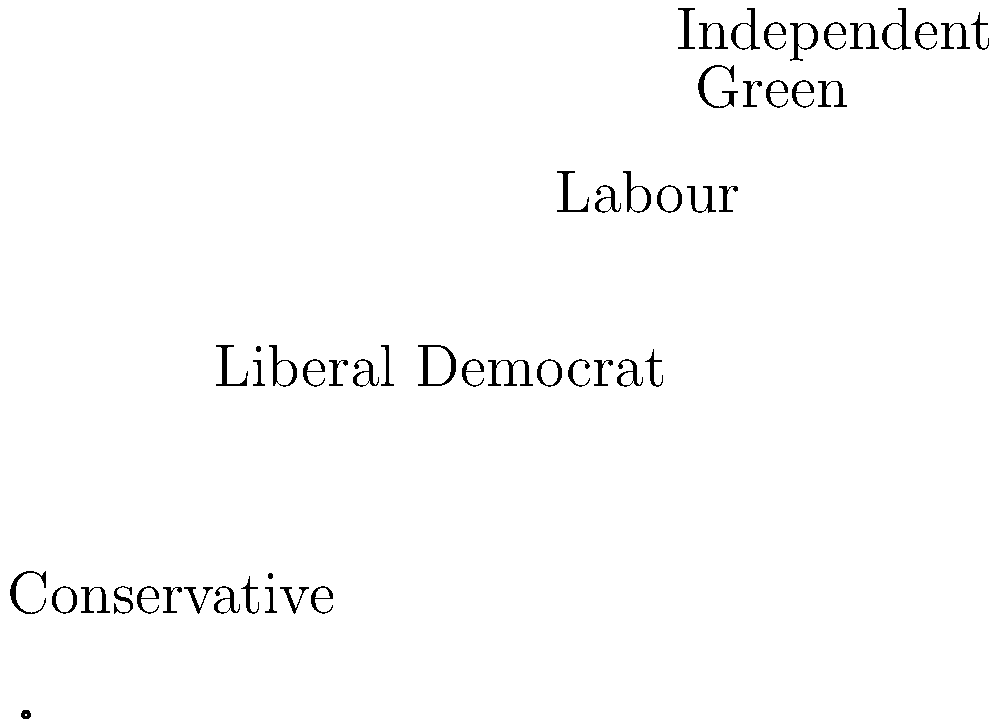Based on the pie chart representing political party support in Wiltshire, which party has the second-largest share of support, and what percentage does it hold? To answer this question, we need to analyze the pie chart showing the distribution of political party support in Wiltshire. Let's break it down step-by-step:

1. Identify all parties represented in the chart:
   - Conservative (blue)
   - Liberal Democrat (yellow)
   - Labour (red)
   - Green (green)
   - Independent (gray)

2. Determine the largest share:
   The largest slice of the pie belongs to the Conservative party, which appears to have about 35% of the support.

3. Identify the second-largest share:
   The second-largest slice is yellow, representing the Liberal Democrat party.

4. Calculate the percentage for the Liberal Democrats:
   The Liberal Democrat slice appears to cover about 30% of the pie chart.

5. Confirm the answer:
   The Liberal Democrat party has the second-largest share of support with approximately 30%.

As a local activist in Wiltshire, this information is crucial for understanding the political landscape and planning grassroots campaigns effectively.
Answer: Liberal Democrat, 30% 